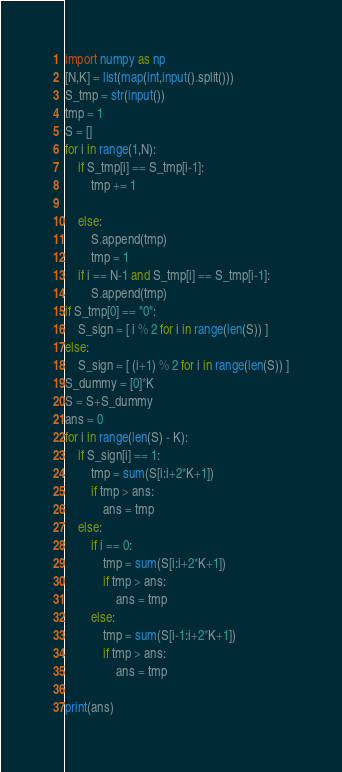Convert code to text. <code><loc_0><loc_0><loc_500><loc_500><_Python_>import numpy as np
[N,K] = list(map(int,input().split()))
S_tmp = str(input())
tmp = 1
S = []
for i in range(1,N):
    if S_tmp[i] == S_tmp[i-1]:
        tmp += 1
        
    else:
        S.append(tmp)
        tmp = 1
    if i == N-1 and S_tmp[i] == S_tmp[i-1]:
        S.append(tmp)
if S_tmp[0] == "0":
    S_sign = [ i % 2 for i in range(len(S)) ]
else:
    S_sign = [ (i+1) % 2 for i in range(len(S)) ]
S_dummy = [0]*K
S = S+S_dummy
ans = 0
for i in range(len(S) - K):
    if S_sign[i] == 1:
        tmp = sum(S[i:i+2*K+1])
        if tmp > ans:
            ans = tmp
    else:
        if i == 0:
            tmp = sum(S[i:i+2*K+1])
            if tmp > ans:
                ans = tmp
        else:
            tmp = sum(S[i-1:i+2*K+1])
            if tmp > ans:
                ans = tmp

print(ans)</code> 